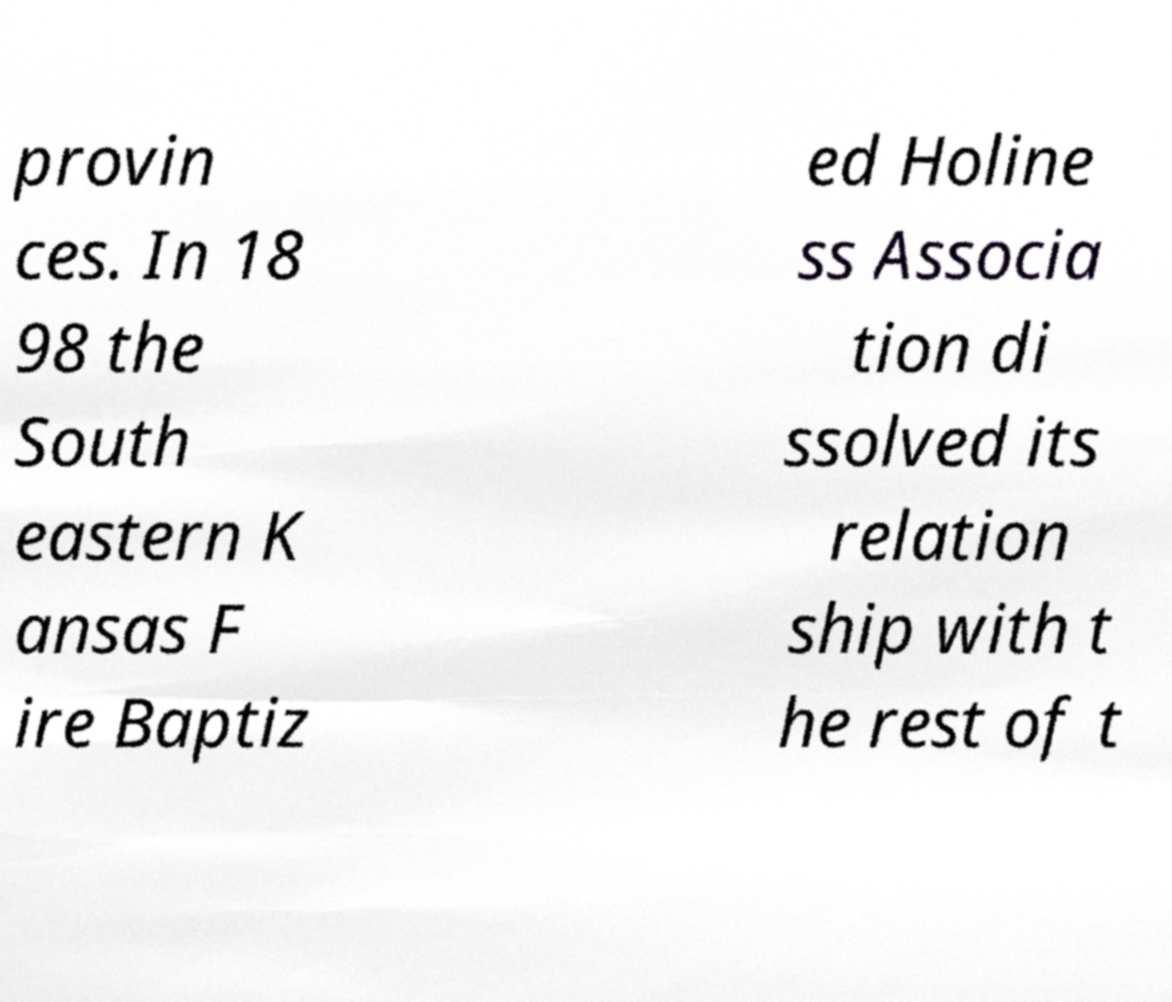For documentation purposes, I need the text within this image transcribed. Could you provide that? provin ces. In 18 98 the South eastern K ansas F ire Baptiz ed Holine ss Associa tion di ssolved its relation ship with t he rest of t 